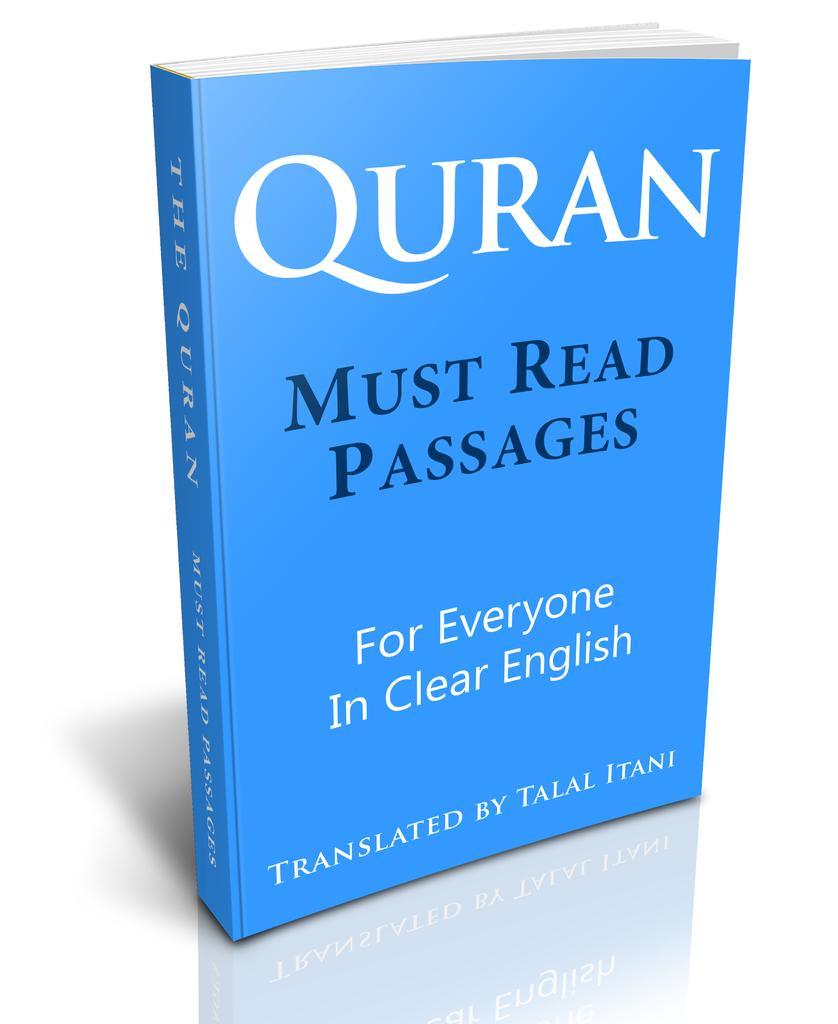How would you summarize this image in a sentence or two? In the picture we can see a Quran, which is blue in color and written on it as must read passages for everyone in English and it is translated by Talal Itani. 